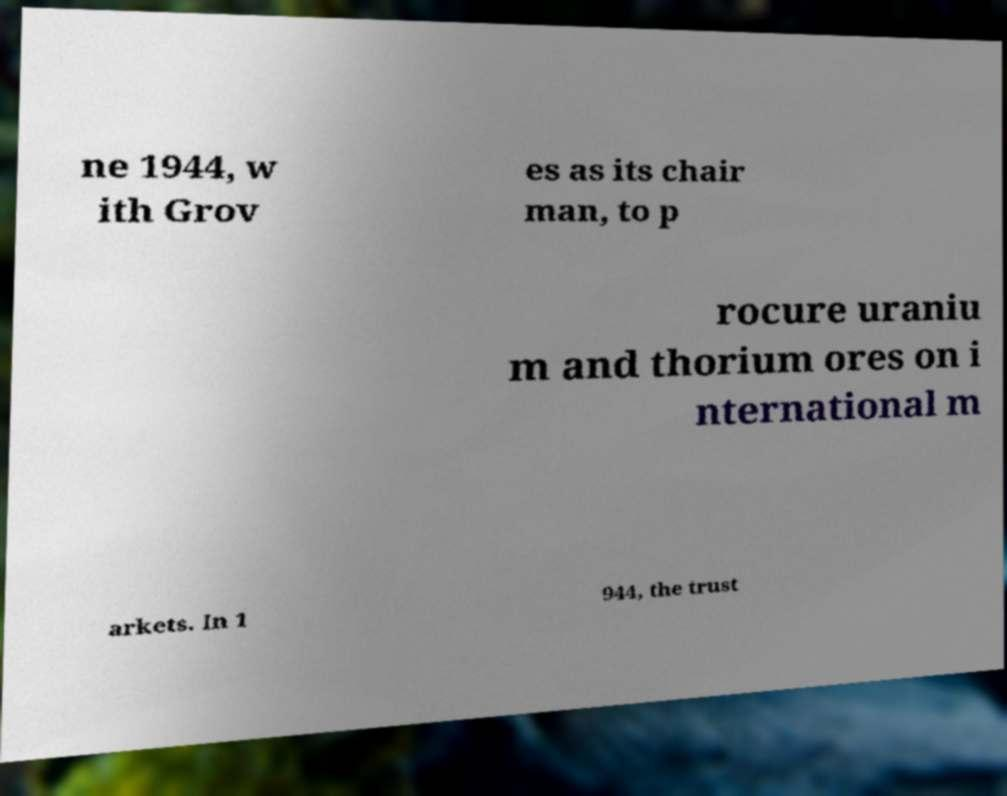Please read and relay the text visible in this image. What does it say? ne 1944, w ith Grov es as its chair man, to p rocure uraniu m and thorium ores on i nternational m arkets. In 1 944, the trust 